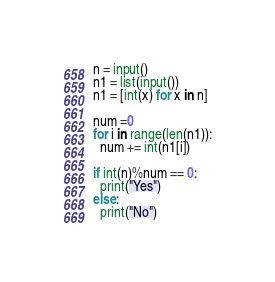Convert code to text. <code><loc_0><loc_0><loc_500><loc_500><_Python_>n = input()
n1 = list(input())
n1 = [int(x) for x in n]

num =0
for i in range(len(n1)):
  num += int(n1[i])

if int(n)%num == 0:
  print("Yes")
else:
  print("No")</code> 